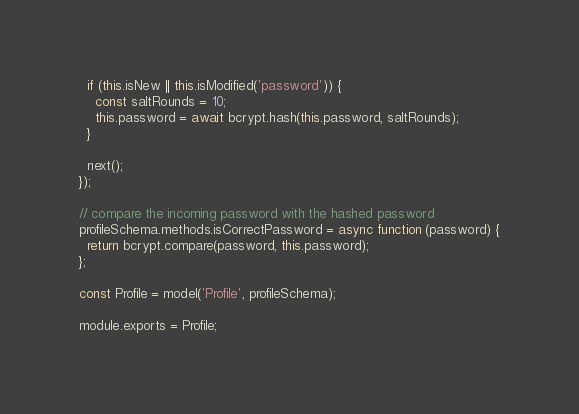Convert code to text. <code><loc_0><loc_0><loc_500><loc_500><_JavaScript_>  if (this.isNew || this.isModified('password')) {
    const saltRounds = 10;
    this.password = await bcrypt.hash(this.password, saltRounds);
  }

  next();
});

// compare the incoming password with the hashed password
profileSchema.methods.isCorrectPassword = async function (password) {
  return bcrypt.compare(password, this.password);
};

const Profile = model('Profile', profileSchema);

module.exports = Profile;
</code> 